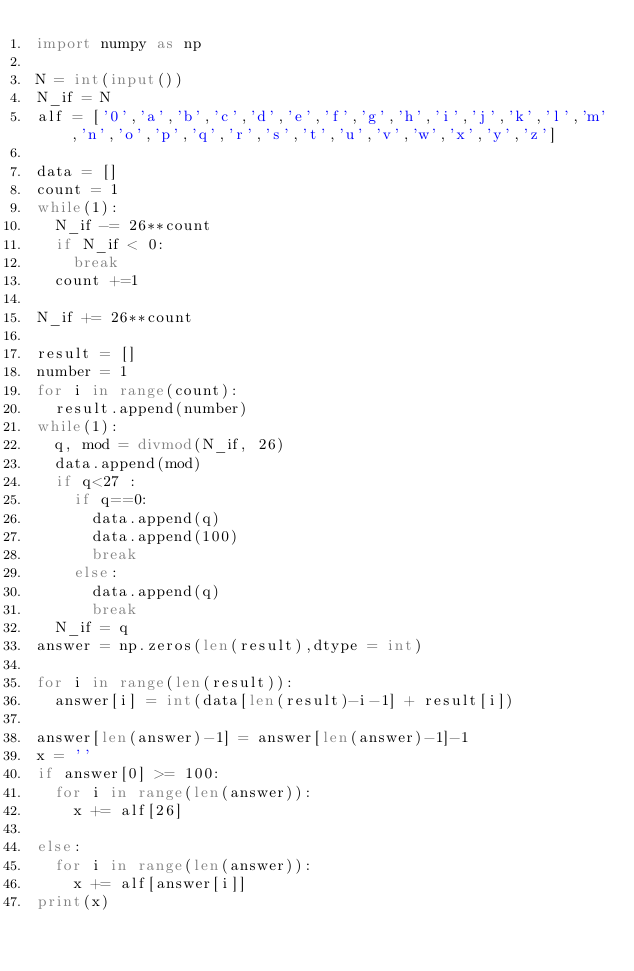Convert code to text. <code><loc_0><loc_0><loc_500><loc_500><_Python_>import numpy as np

N = int(input())
N_if = N
alf = ['0','a','b','c','d','e','f','g','h','i','j','k','l','m','n','o','p','q','r','s','t','u','v','w','x','y','z']

data = []
count = 1
while(1):
  N_if -= 26**count
  if N_if < 0:    
    break
  count +=1
  
N_if += 26**count

result = []
number = 1
for i in range(count):
  result.append(number)
while(1):
  q, mod = divmod(N_if, 26)
  data.append(mod)
  if q<27 :
    if q==0:
      data.append(q)
      data.append(100)
      break
    else:
      data.append(q)
      break
  N_if = q
answer = np.zeros(len(result),dtype = int)

for i in range(len(result)):
  answer[i] = int(data[len(result)-i-1] + result[i])

answer[len(answer)-1] = answer[len(answer)-1]-1
x = ''
if answer[0] >= 100:
  for i in range(len(answer)):
    x += alf[26]
    
else:
  for i in range(len(answer)):
    x += alf[answer[i]]
print(x)</code> 